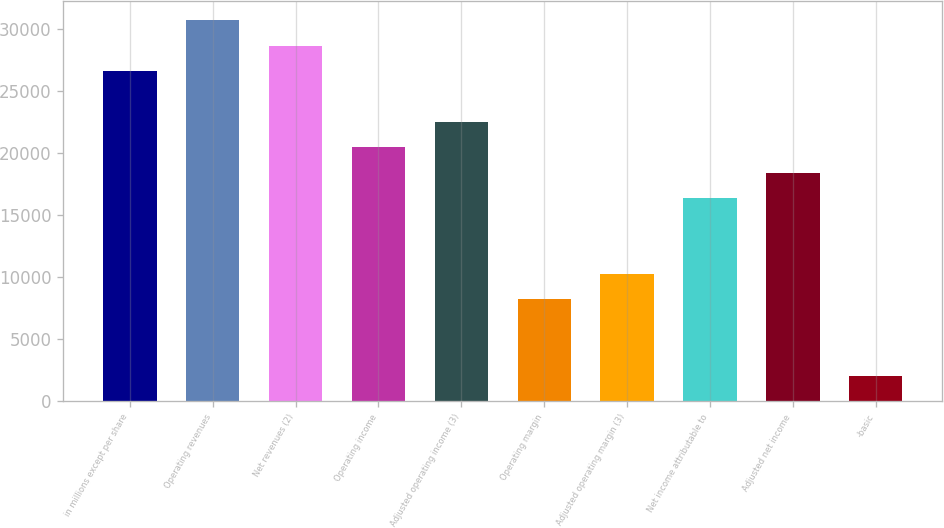Convert chart to OTSL. <chart><loc_0><loc_0><loc_500><loc_500><bar_chart><fcel>in millions except per share<fcel>Operating revenues<fcel>Net revenues (2)<fcel>Operating income<fcel>Adjusted operating income (3)<fcel>Operating margin<fcel>Adjusted operating margin (3)<fcel>Net income attributable to<fcel>Adjusted net income<fcel>-basic<nl><fcel>26600.9<fcel>30693.2<fcel>28647.1<fcel>20462.5<fcel>22508.6<fcel>8185.57<fcel>10231.7<fcel>16370.2<fcel>18416.3<fcel>2047.12<nl></chart> 